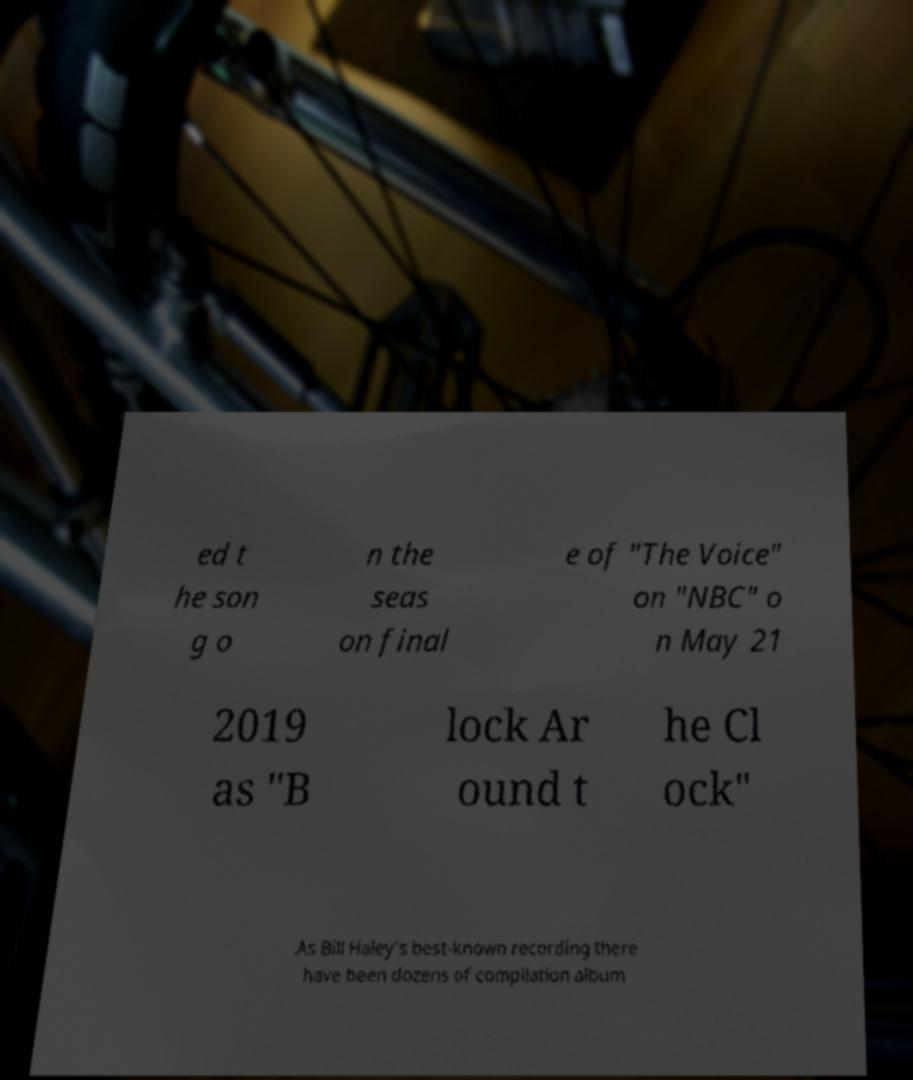What messages or text are displayed in this image? I need them in a readable, typed format. ed t he son g o n the seas on final e of "The Voice" on "NBC" o n May 21 2019 as "B lock Ar ound t he Cl ock" .As Bill Haley's best-known recording there have been dozens of compilation album 